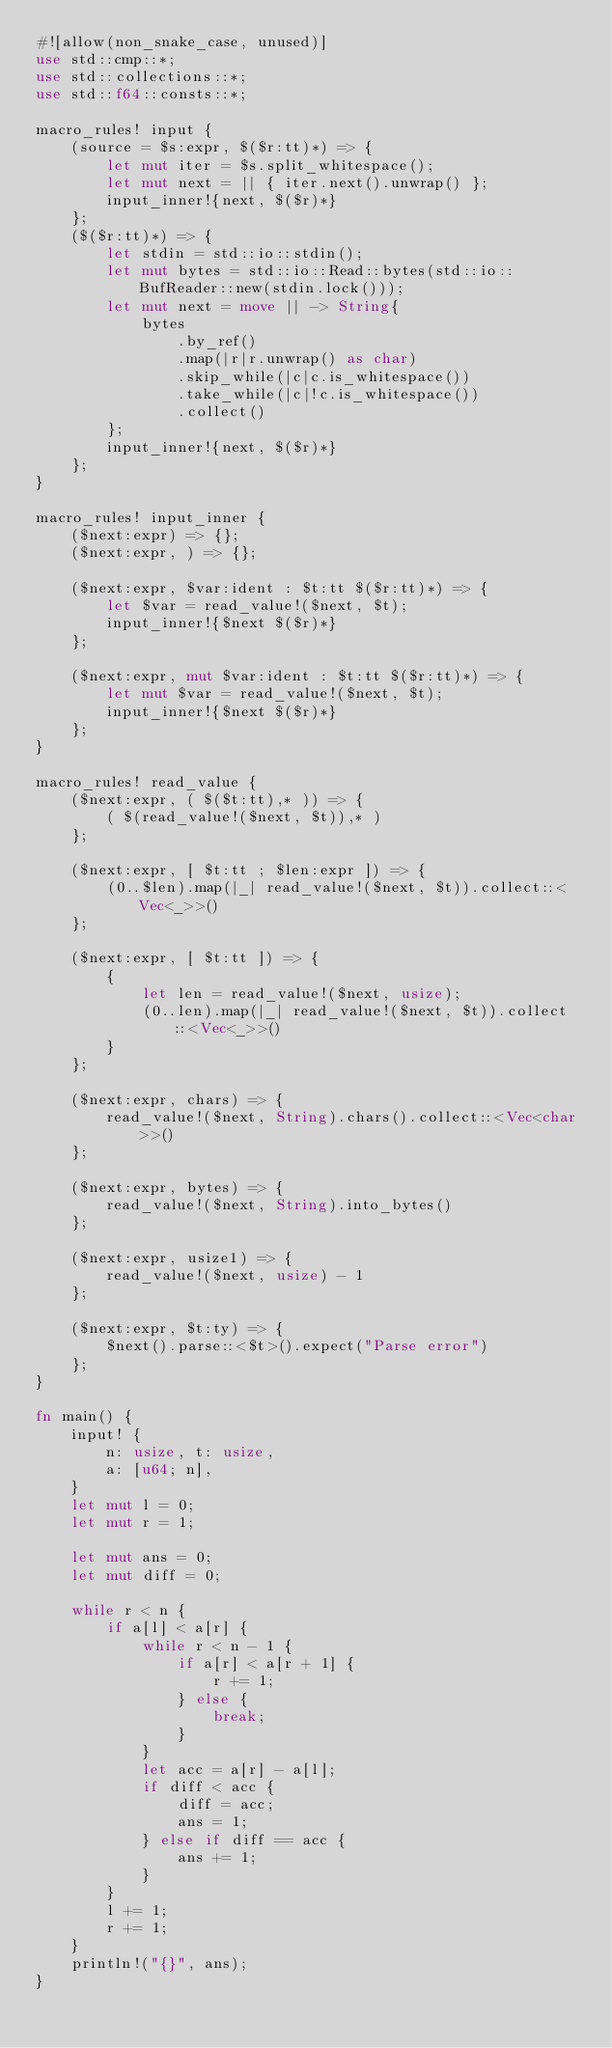<code> <loc_0><loc_0><loc_500><loc_500><_Rust_>#![allow(non_snake_case, unused)]
use std::cmp::*;
use std::collections::*;
use std::f64::consts::*;

macro_rules! input {
    (source = $s:expr, $($r:tt)*) => {
        let mut iter = $s.split_whitespace();
        let mut next = || { iter.next().unwrap() };
        input_inner!{next, $($r)*}
    };
    ($($r:tt)*) => {
        let stdin = std::io::stdin();
        let mut bytes = std::io::Read::bytes(std::io::BufReader::new(stdin.lock()));
        let mut next = move || -> String{
            bytes
                .by_ref()
                .map(|r|r.unwrap() as char)
                .skip_while(|c|c.is_whitespace())
                .take_while(|c|!c.is_whitespace())
                .collect()
        };
        input_inner!{next, $($r)*}
    };
}

macro_rules! input_inner {
    ($next:expr) => {};
    ($next:expr, ) => {};

    ($next:expr, $var:ident : $t:tt $($r:tt)*) => {
        let $var = read_value!($next, $t);
        input_inner!{$next $($r)*}
    };

    ($next:expr, mut $var:ident : $t:tt $($r:tt)*) => {
        let mut $var = read_value!($next, $t);
        input_inner!{$next $($r)*}
    };
}

macro_rules! read_value {
    ($next:expr, ( $($t:tt),* )) => {
        ( $(read_value!($next, $t)),* )
    };

    ($next:expr, [ $t:tt ; $len:expr ]) => {
        (0..$len).map(|_| read_value!($next, $t)).collect::<Vec<_>>()
    };

    ($next:expr, [ $t:tt ]) => {
        {
            let len = read_value!($next, usize);
            (0..len).map(|_| read_value!($next, $t)).collect::<Vec<_>>()
        }
    };

    ($next:expr, chars) => {
        read_value!($next, String).chars().collect::<Vec<char>>()
    };

    ($next:expr, bytes) => {
        read_value!($next, String).into_bytes()
    };

    ($next:expr, usize1) => {
        read_value!($next, usize) - 1
    };

    ($next:expr, $t:ty) => {
        $next().parse::<$t>().expect("Parse error")
    };
}

fn main() {
    input! {
        n: usize, t: usize,
        a: [u64; n],
    }
    let mut l = 0;
    let mut r = 1;

    let mut ans = 0;
    let mut diff = 0;

    while r < n {
        if a[l] < a[r] {
            while r < n - 1 {
                if a[r] < a[r + 1] {
                    r += 1;
                } else {
                    break;
                }
            }
            let acc = a[r] - a[l];
            if diff < acc {
                diff = acc;
                ans = 1;
            } else if diff == acc {
                ans += 1;
            }
        }
        l += 1;
        r += 1;
    }
    println!("{}", ans);
}
</code> 